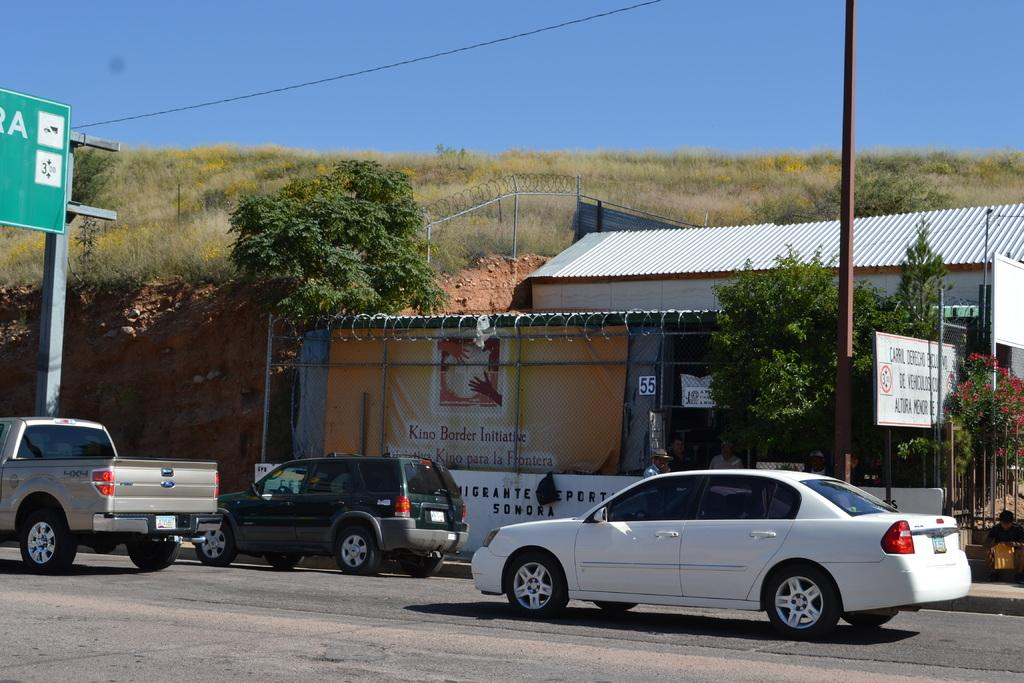What is the main feature of the image? There is a road in the image. How many vehicles can be seen on the road? There are three vehicles on the road. What can be seen in the background of the image? There are mountains, shops, and trees in the background of the image. What is the color of the sky in the image? The sky is blue in the image. What type of wave can be seen crashing on the shore in the image? There is no wave or shore present in the image; it features a road, vehicles, and a background with mountains, shops, and trees. 